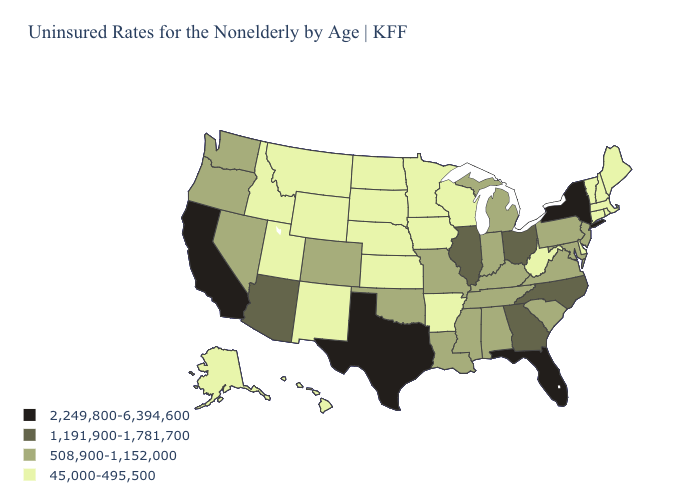What is the highest value in the USA?
Keep it brief. 2,249,800-6,394,600. Which states have the lowest value in the USA?
Short answer required. Alaska, Arkansas, Connecticut, Delaware, Hawaii, Idaho, Iowa, Kansas, Maine, Massachusetts, Minnesota, Montana, Nebraska, New Hampshire, New Mexico, North Dakota, Rhode Island, South Dakota, Utah, Vermont, West Virginia, Wisconsin, Wyoming. Name the states that have a value in the range 45,000-495,500?
Short answer required. Alaska, Arkansas, Connecticut, Delaware, Hawaii, Idaho, Iowa, Kansas, Maine, Massachusetts, Minnesota, Montana, Nebraska, New Hampshire, New Mexico, North Dakota, Rhode Island, South Dakota, Utah, Vermont, West Virginia, Wisconsin, Wyoming. Name the states that have a value in the range 45,000-495,500?
Concise answer only. Alaska, Arkansas, Connecticut, Delaware, Hawaii, Idaho, Iowa, Kansas, Maine, Massachusetts, Minnesota, Montana, Nebraska, New Hampshire, New Mexico, North Dakota, Rhode Island, South Dakota, Utah, Vermont, West Virginia, Wisconsin, Wyoming. What is the lowest value in the USA?
Write a very short answer. 45,000-495,500. Name the states that have a value in the range 45,000-495,500?
Be succinct. Alaska, Arkansas, Connecticut, Delaware, Hawaii, Idaho, Iowa, Kansas, Maine, Massachusetts, Minnesota, Montana, Nebraska, New Hampshire, New Mexico, North Dakota, Rhode Island, South Dakota, Utah, Vermont, West Virginia, Wisconsin, Wyoming. Name the states that have a value in the range 2,249,800-6,394,600?
Short answer required. California, Florida, New York, Texas. Does Maryland have a lower value than Colorado?
Concise answer only. No. What is the value of Rhode Island?
Be succinct. 45,000-495,500. Among the states that border Missouri , does Iowa have the highest value?
Answer briefly. No. Which states have the lowest value in the USA?
Give a very brief answer. Alaska, Arkansas, Connecticut, Delaware, Hawaii, Idaho, Iowa, Kansas, Maine, Massachusetts, Minnesota, Montana, Nebraska, New Hampshire, New Mexico, North Dakota, Rhode Island, South Dakota, Utah, Vermont, West Virginia, Wisconsin, Wyoming. Name the states that have a value in the range 45,000-495,500?
Answer briefly. Alaska, Arkansas, Connecticut, Delaware, Hawaii, Idaho, Iowa, Kansas, Maine, Massachusetts, Minnesota, Montana, Nebraska, New Hampshire, New Mexico, North Dakota, Rhode Island, South Dakota, Utah, Vermont, West Virginia, Wisconsin, Wyoming. Name the states that have a value in the range 45,000-495,500?
Concise answer only. Alaska, Arkansas, Connecticut, Delaware, Hawaii, Idaho, Iowa, Kansas, Maine, Massachusetts, Minnesota, Montana, Nebraska, New Hampshire, New Mexico, North Dakota, Rhode Island, South Dakota, Utah, Vermont, West Virginia, Wisconsin, Wyoming. Which states have the lowest value in the Northeast?
Give a very brief answer. Connecticut, Maine, Massachusetts, New Hampshire, Rhode Island, Vermont. What is the value of Wisconsin?
Short answer required. 45,000-495,500. 